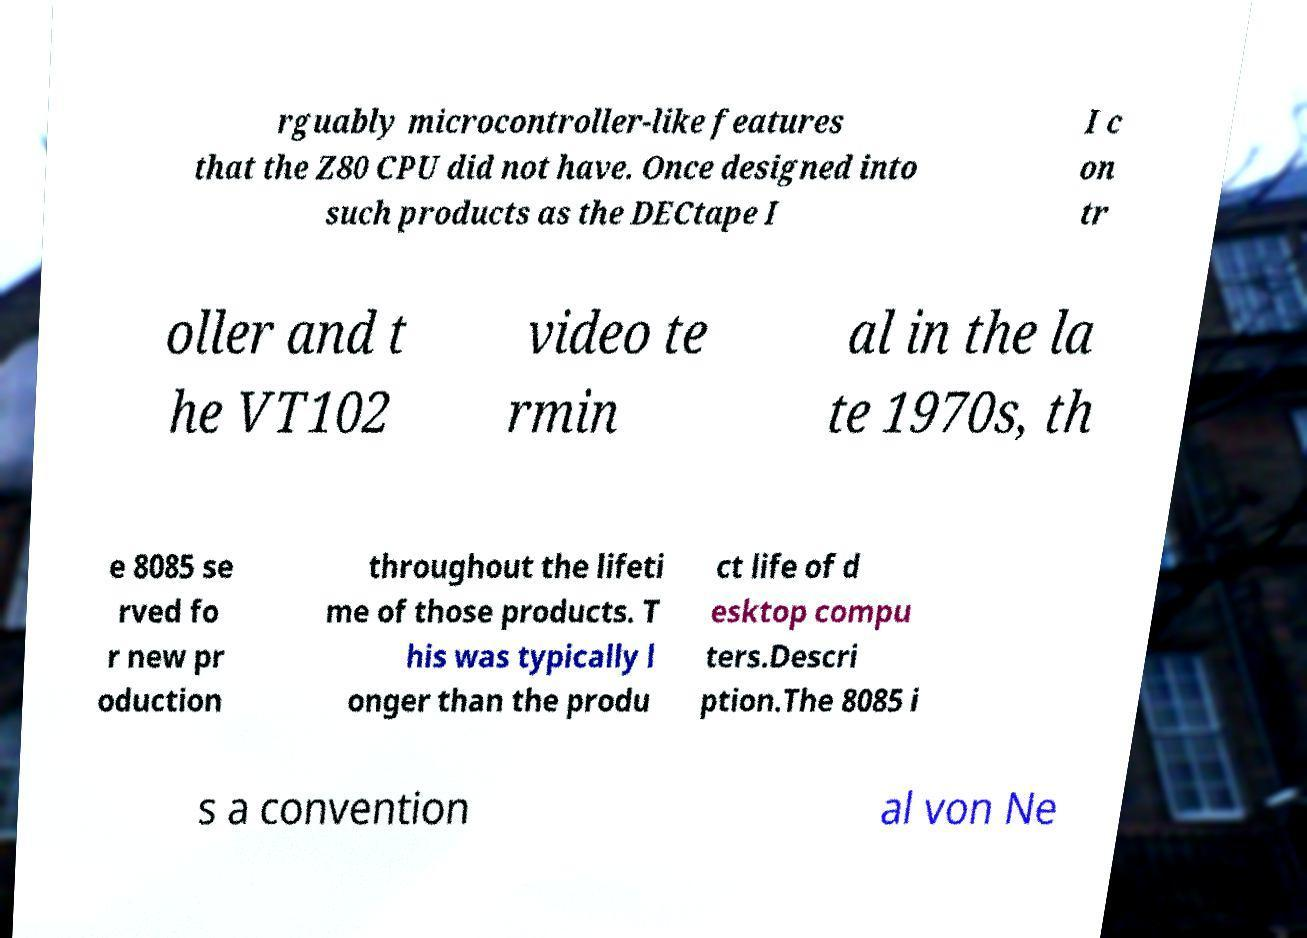What messages or text are displayed in this image? I need them in a readable, typed format. rguably microcontroller-like features that the Z80 CPU did not have. Once designed into such products as the DECtape I I c on tr oller and t he VT102 video te rmin al in the la te 1970s, th e 8085 se rved fo r new pr oduction throughout the lifeti me of those products. T his was typically l onger than the produ ct life of d esktop compu ters.Descri ption.The 8085 i s a convention al von Ne 